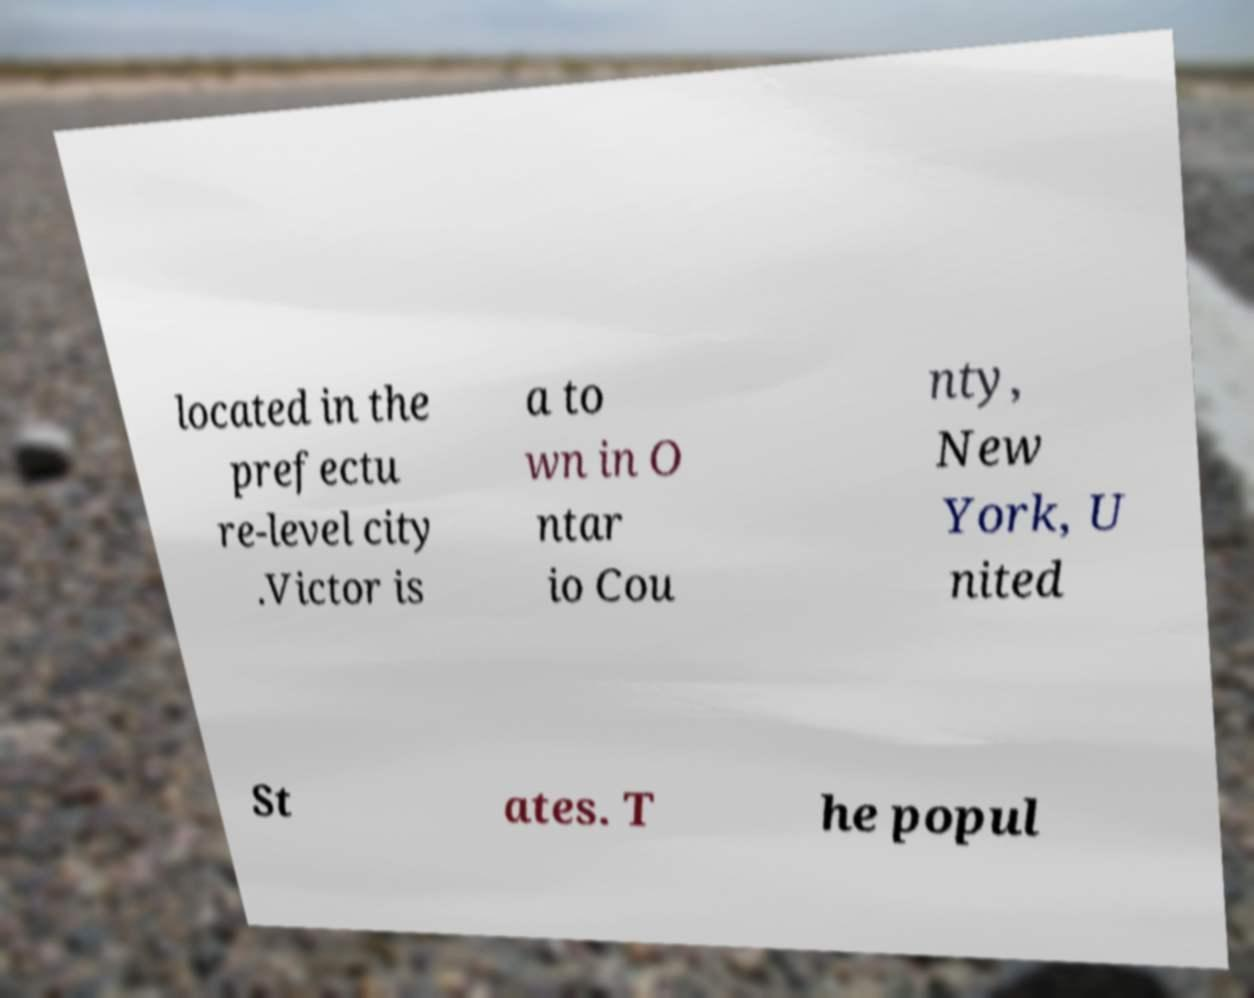I need the written content from this picture converted into text. Can you do that? located in the prefectu re-level city .Victor is a to wn in O ntar io Cou nty, New York, U nited St ates. T he popul 